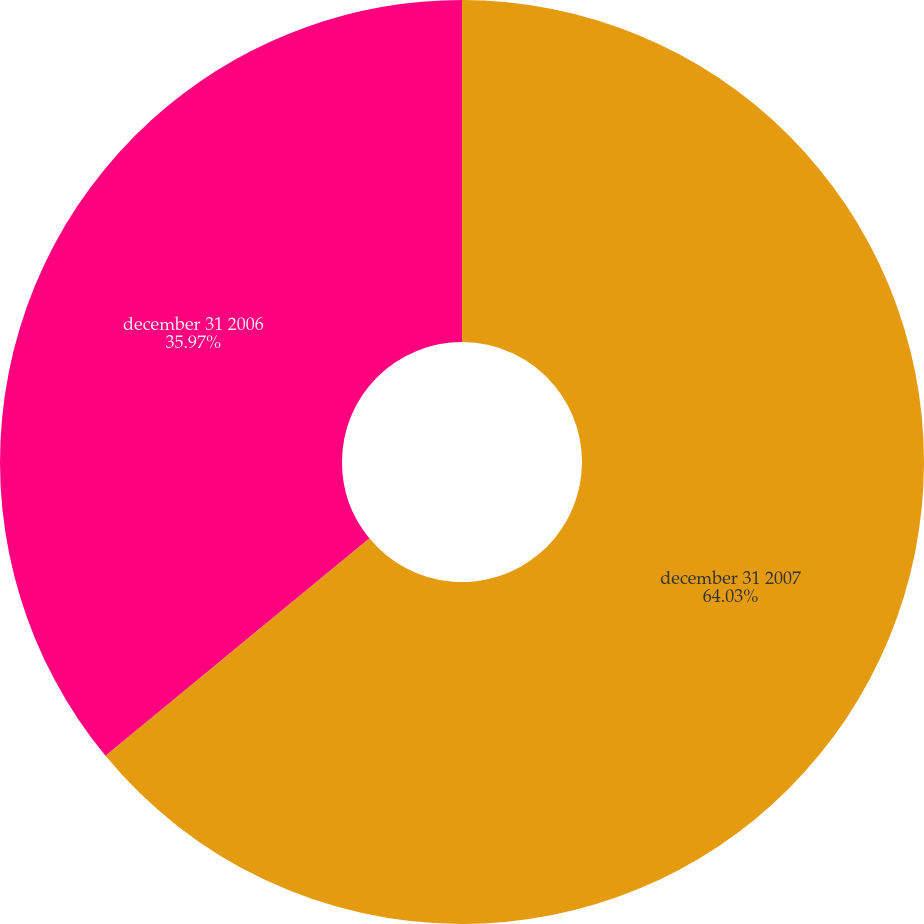Convert chart to OTSL. <chart><loc_0><loc_0><loc_500><loc_500><pie_chart><fcel>december 31 2007<fcel>december 31 2006<nl><fcel>64.03%<fcel>35.97%<nl></chart> 